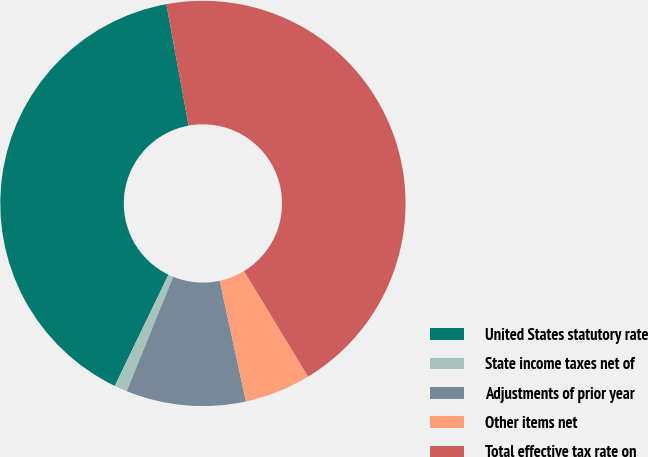Convert chart. <chart><loc_0><loc_0><loc_500><loc_500><pie_chart><fcel>United States statutory rate<fcel>State income taxes net of<fcel>Adjustments of prior year<fcel>Other items net<fcel>Total effective tax rate on<nl><fcel>39.95%<fcel>1.03%<fcel>9.54%<fcel>5.28%<fcel>44.2%<nl></chart> 